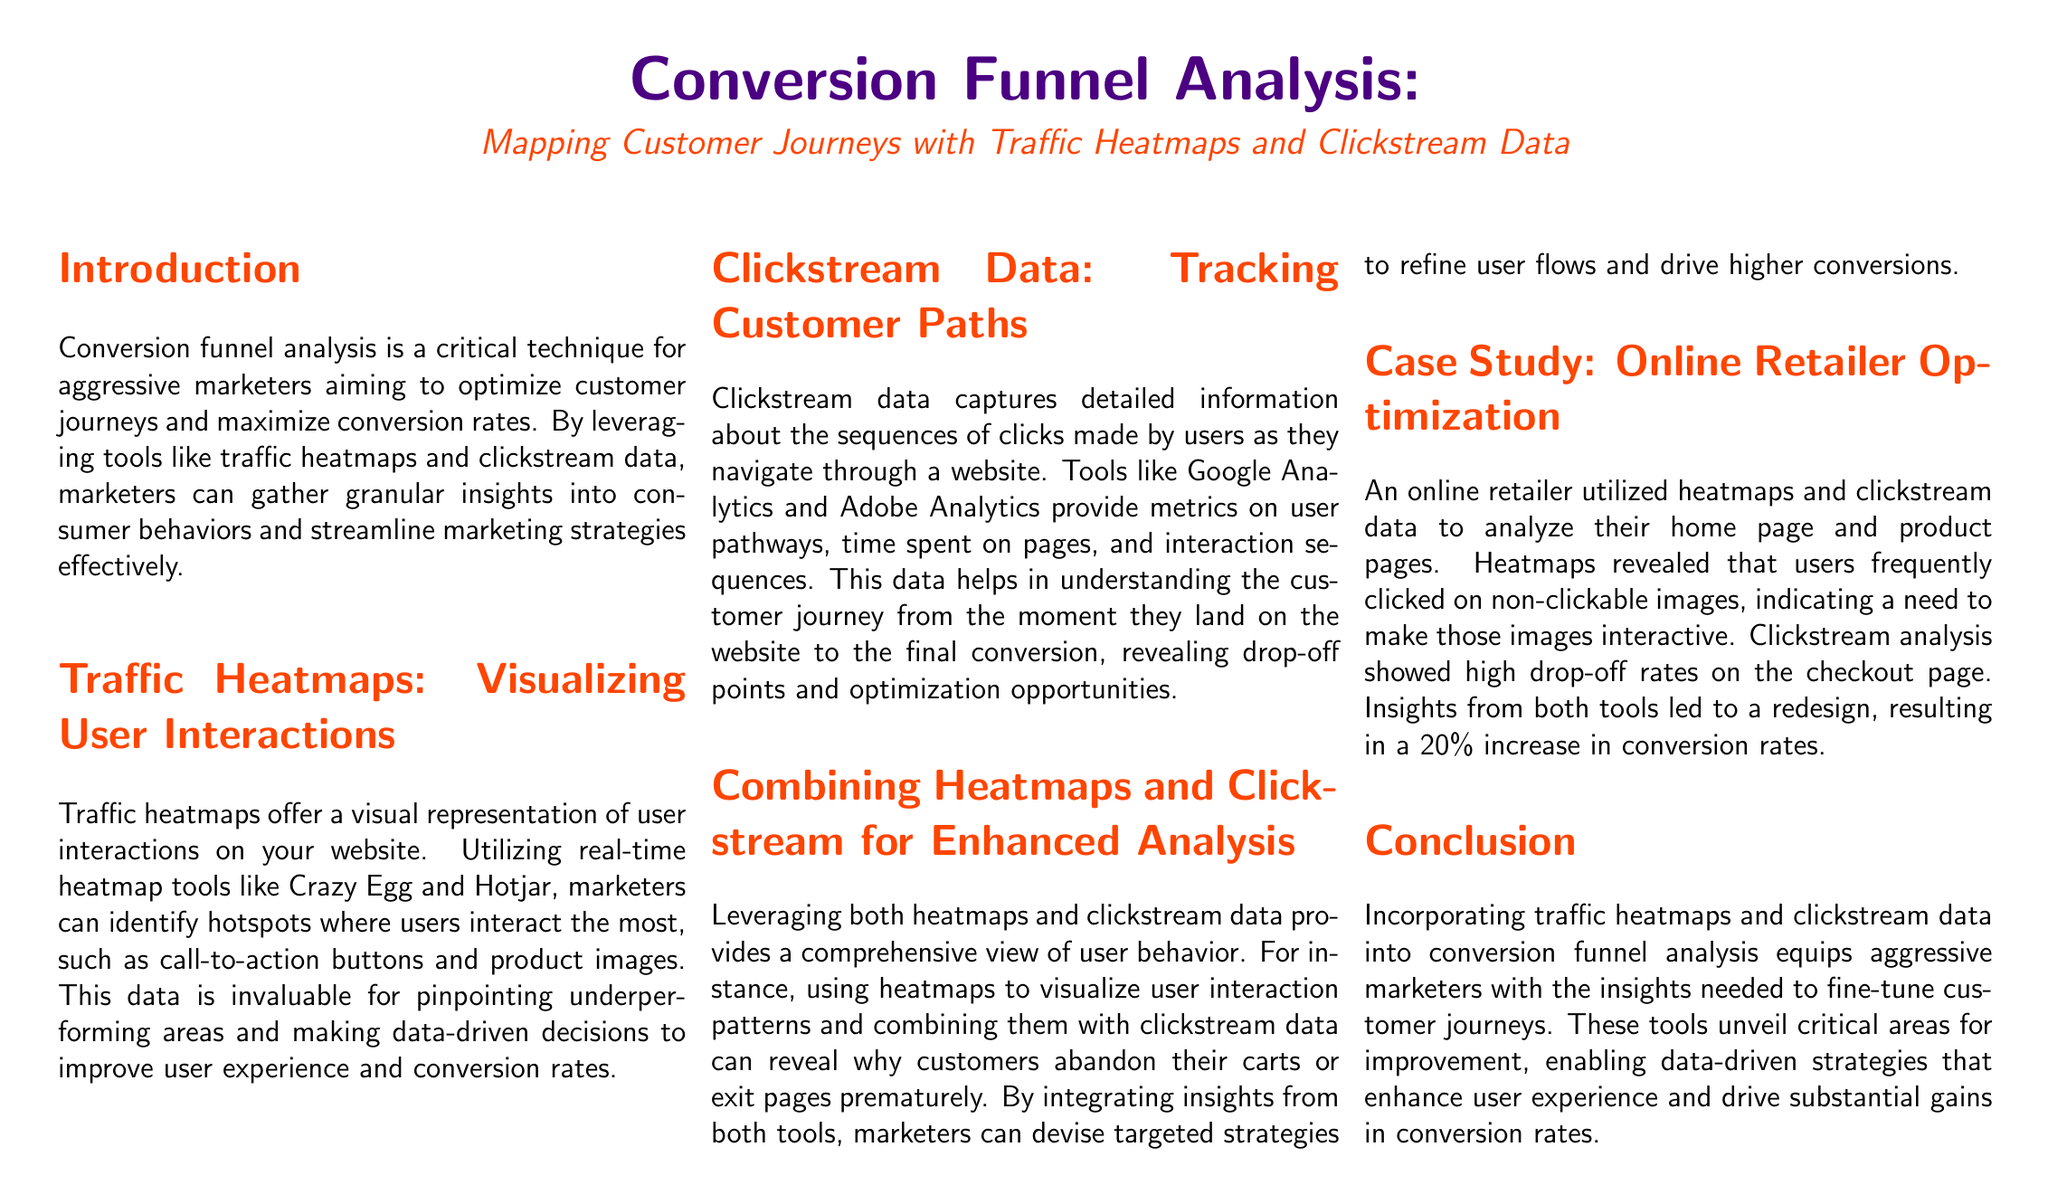What is the primary focus of the report? The report focuses on conversion funnel analysis, particularly through the use of traffic heatmaps and clickstream data.
Answer: Conversion funnel analysis What tools are mentioned for traffic heatmaps? The document lists Crazy Egg and Hotjar as tools for creating traffic heatmaps.
Answer: Crazy Egg and Hotjar What type of data does clickstream data provide? Clickstream data provides detailed information about the sequences of clicks made by users on a website.
Answer: Sequences of clicks What increase in conversion rates did the online retailer achieve after implementing the recommendations? The online retailer achieved a 20% increase in conversion rates from the adjustments made based on the analysis.
Answer: 20% What is the main advantage of combining heatmaps and clickstream data? Combining these tools provides a comprehensive view of user behavior, helping to understand customer journeys better.
Answer: Comprehensive view What aspect of user experience do heatmaps help to identify? Heatmaps help identify hotspots where users interact the most on a website.
Answer: Hotspots Which page did the clickstream analysis indicate a high drop-off rate? The clickstream analysis showed high drop-off rates specifically on the checkout page.
Answer: Checkout page What strategy did the report suggest to marketers for refining user flows? The report suggests devising targeted strategies based on insights gained from both heatmaps and clickstream data.
Answer: Targeted strategies What is the document’s target audience? The primary audience for the report is aggressive marketers seeking to optimize customer journeys.
Answer: Aggressive marketers 